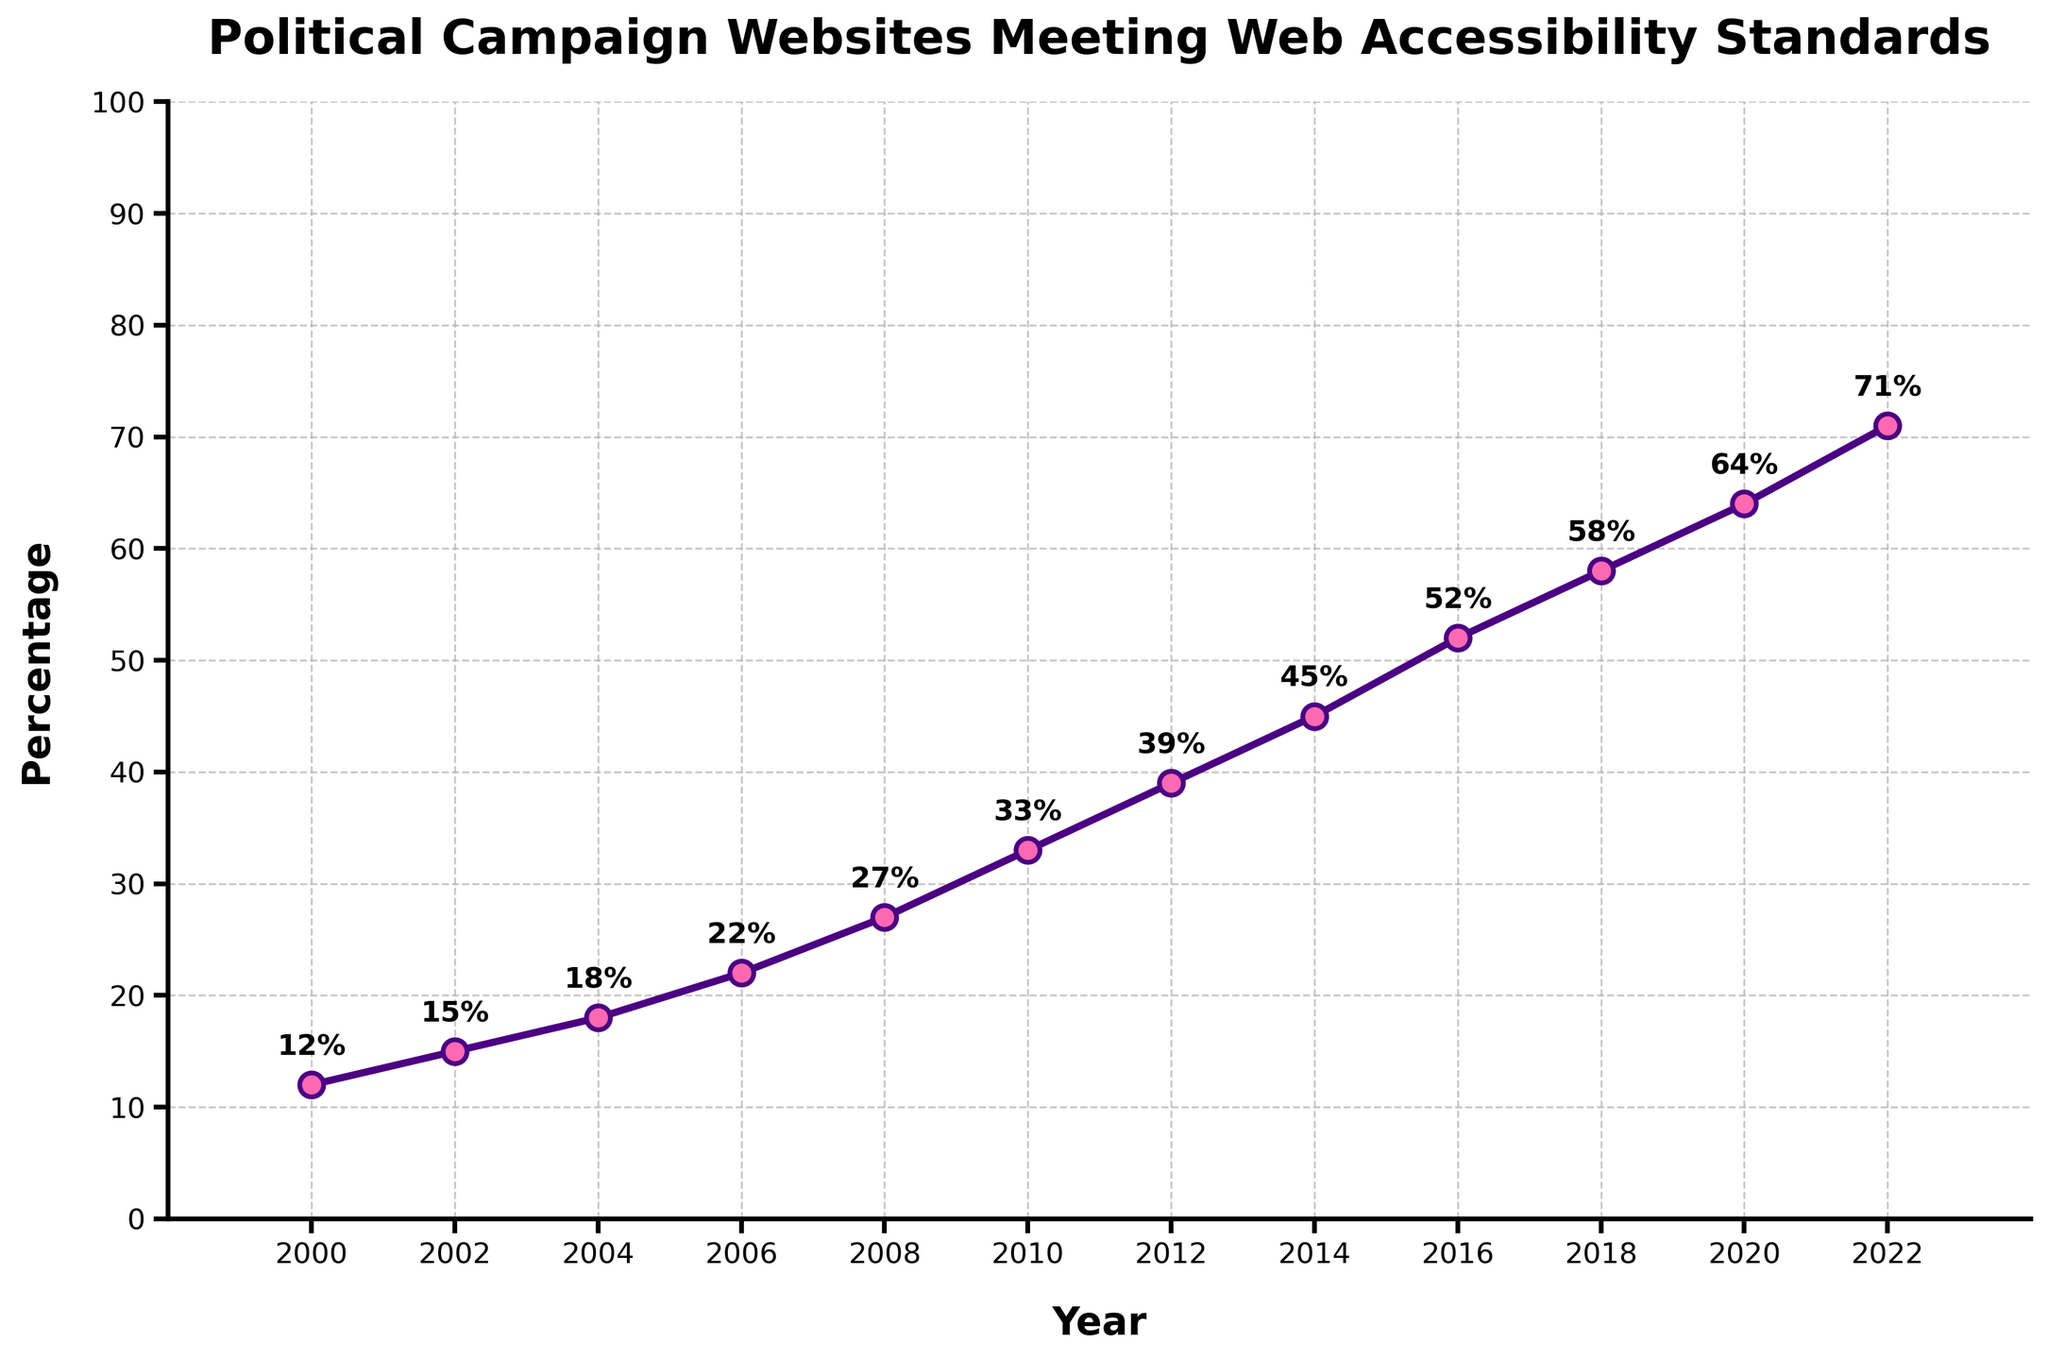Which year did the percentage of political campaign websites meeting web accessibility standards surpass 50%? The figure shows various percentages for each year. Locate the year where the percentage first surpasses 50%. In this case, it is 2016 when the percentage reaches 52%.
Answer: 2016 How much did the percentage increase from 2000 to 2010? Look at the values for 2000 and 2010, which are 12% and 33%, respectively. Calculate the difference: 33% - 12% = 21%.
Answer: 21% By what percentage did web accessibility standards improve between 2014 and 2018? The values for 2014 and 2018 are 45% and 58%, respectively. Subtract the 2014 value from the 2018 value: 58% - 45% = 13%.
Answer: 13% Compare the percentage increases from 2002 to 2006 against 2010 to 2014. Which period had a greater increase? From 2002 to 2006, the values are 15% and 22%, a difference of 22% - 15% = 7%. From 2010 to 2014, the values are 33% and 45%, a difference of 45% - 33% = 12%. The period from 2010 to 2014 had a greater increase.
Answer: 2010 to 2014 What is the average percentage of political campaign websites meeting web accessibility standards for the years 2000, 2010, and 2020? The values for 2000, 2010, and 2020 are 12%, 33%, and 64%, respectively. Calculate the average: (12 + 33 + 64) / 3 = 109 / 3 ≈ 36.3%.
Answer: 36.3% Identify the trend of the percentage increase in web accessibility standards from 2000 to 2022. Is it linear, exponential, or variable? Observe the progression of values from 2000 to 2022. The values show a consistent and steady increase each year without abrupt changes, suggesting a linear trend.
Answer: Linear In which two consecutive years was the smallest percentage increase observed? Examine all the consecutive years. The smallest increase is between 2002 and 2004, where the increase is 18% - 15% = 3%.
Answer: 2002 and 2004 Which decade saw the highest cumulative increase in the percentage of websites meeting web accessibility standards? Analyze decade-wise cumulative increases: 
2000-2010: 33% - 12% = 21%. 
2010-2020: 64% - 33% = 31%. 
2012-2022: 71% - 39% = 32%. 
The decade from 2012 to 2022 had the highest cumulative increase with 32%.
Answer: 2012 to 2022 How does the percentage in 2008 compare to the percentage in 2016? Look at the values denoted for 2008 and 2016, which are 27% and 52%, respectively. 2016 had a significantly higher percentage than 2008.
Answer: 2016 is higher What visual cue indicates the years on the x-axis? The figure uses markers (dots) to indicate specific years along the x-axis.
Answer: Markers (dots) 